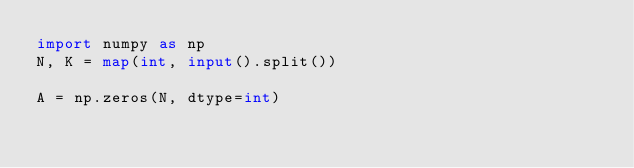Convert code to text. <code><loc_0><loc_0><loc_500><loc_500><_Python_>import numpy as np
N, K = map(int, input().split())
 
A = np.zeros(N, dtype=int)</code> 